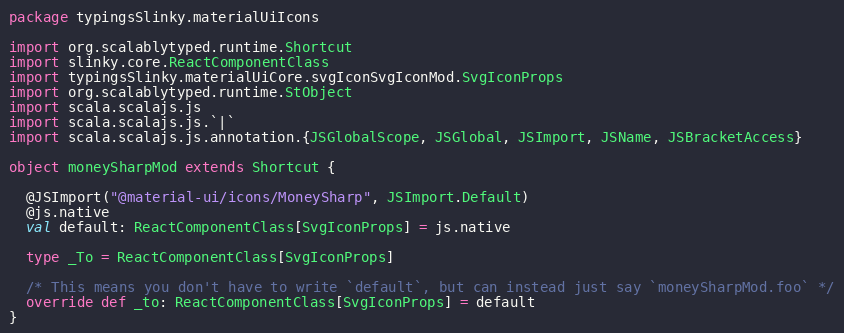<code> <loc_0><loc_0><loc_500><loc_500><_Scala_>package typingsSlinky.materialUiIcons

import org.scalablytyped.runtime.Shortcut
import slinky.core.ReactComponentClass
import typingsSlinky.materialUiCore.svgIconSvgIconMod.SvgIconProps
import org.scalablytyped.runtime.StObject
import scala.scalajs.js
import scala.scalajs.js.`|`
import scala.scalajs.js.annotation.{JSGlobalScope, JSGlobal, JSImport, JSName, JSBracketAccess}

object moneySharpMod extends Shortcut {
  
  @JSImport("@material-ui/icons/MoneySharp", JSImport.Default)
  @js.native
  val default: ReactComponentClass[SvgIconProps] = js.native
  
  type _To = ReactComponentClass[SvgIconProps]
  
  /* This means you don't have to write `default`, but can instead just say `moneySharpMod.foo` */
  override def _to: ReactComponentClass[SvgIconProps] = default
}
</code> 